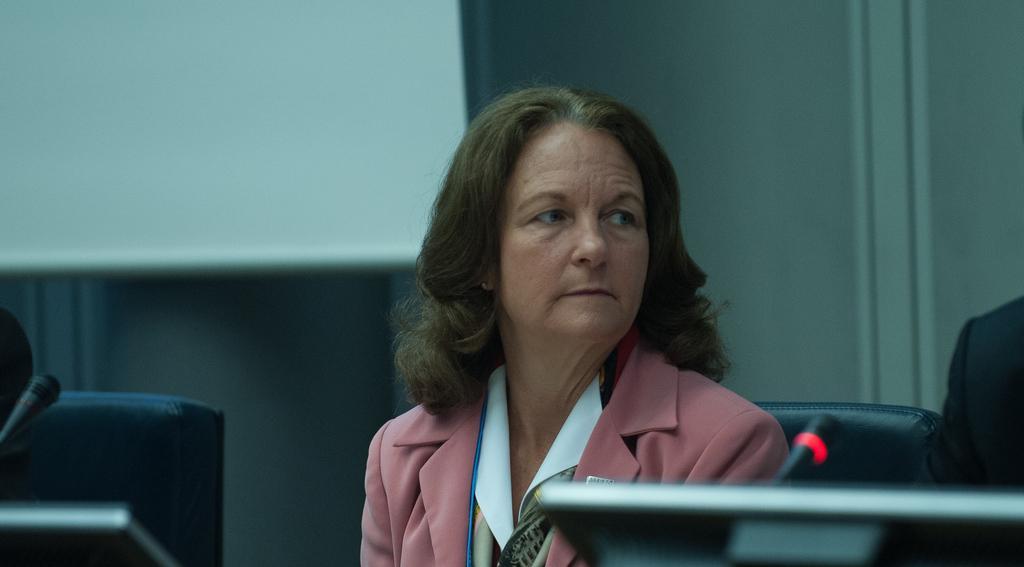Please provide a concise description of this image. In this image there is a person sitting on one of the chairs in a room, there are microphone and laptops on the table, there is a screen and a wall. 